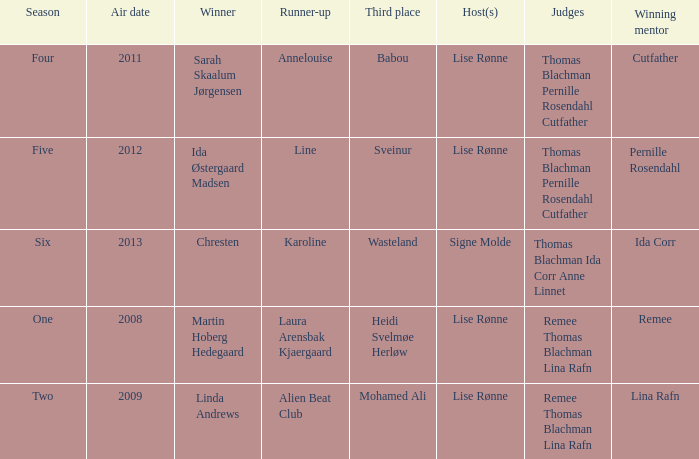Which season did Ida Corr win? Six. 